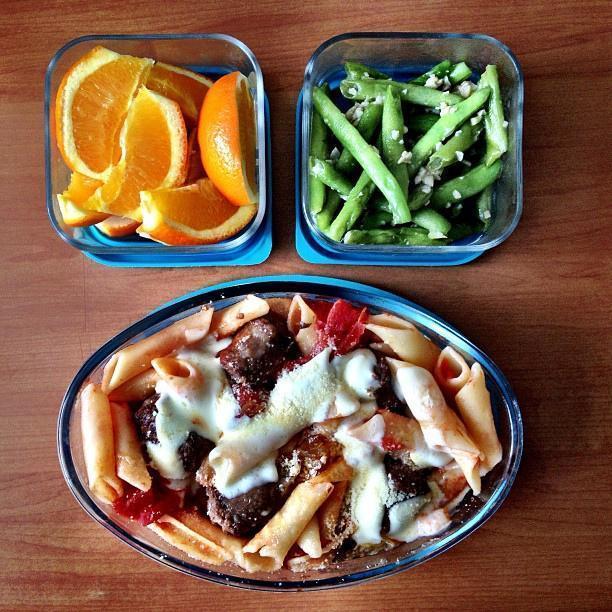How many bowls can be seen?
Give a very brief answer. 2. How many oranges are in the photo?
Give a very brief answer. 2. How many dining tables are there?
Give a very brief answer. 1. How many men are sitting?
Give a very brief answer. 0. 